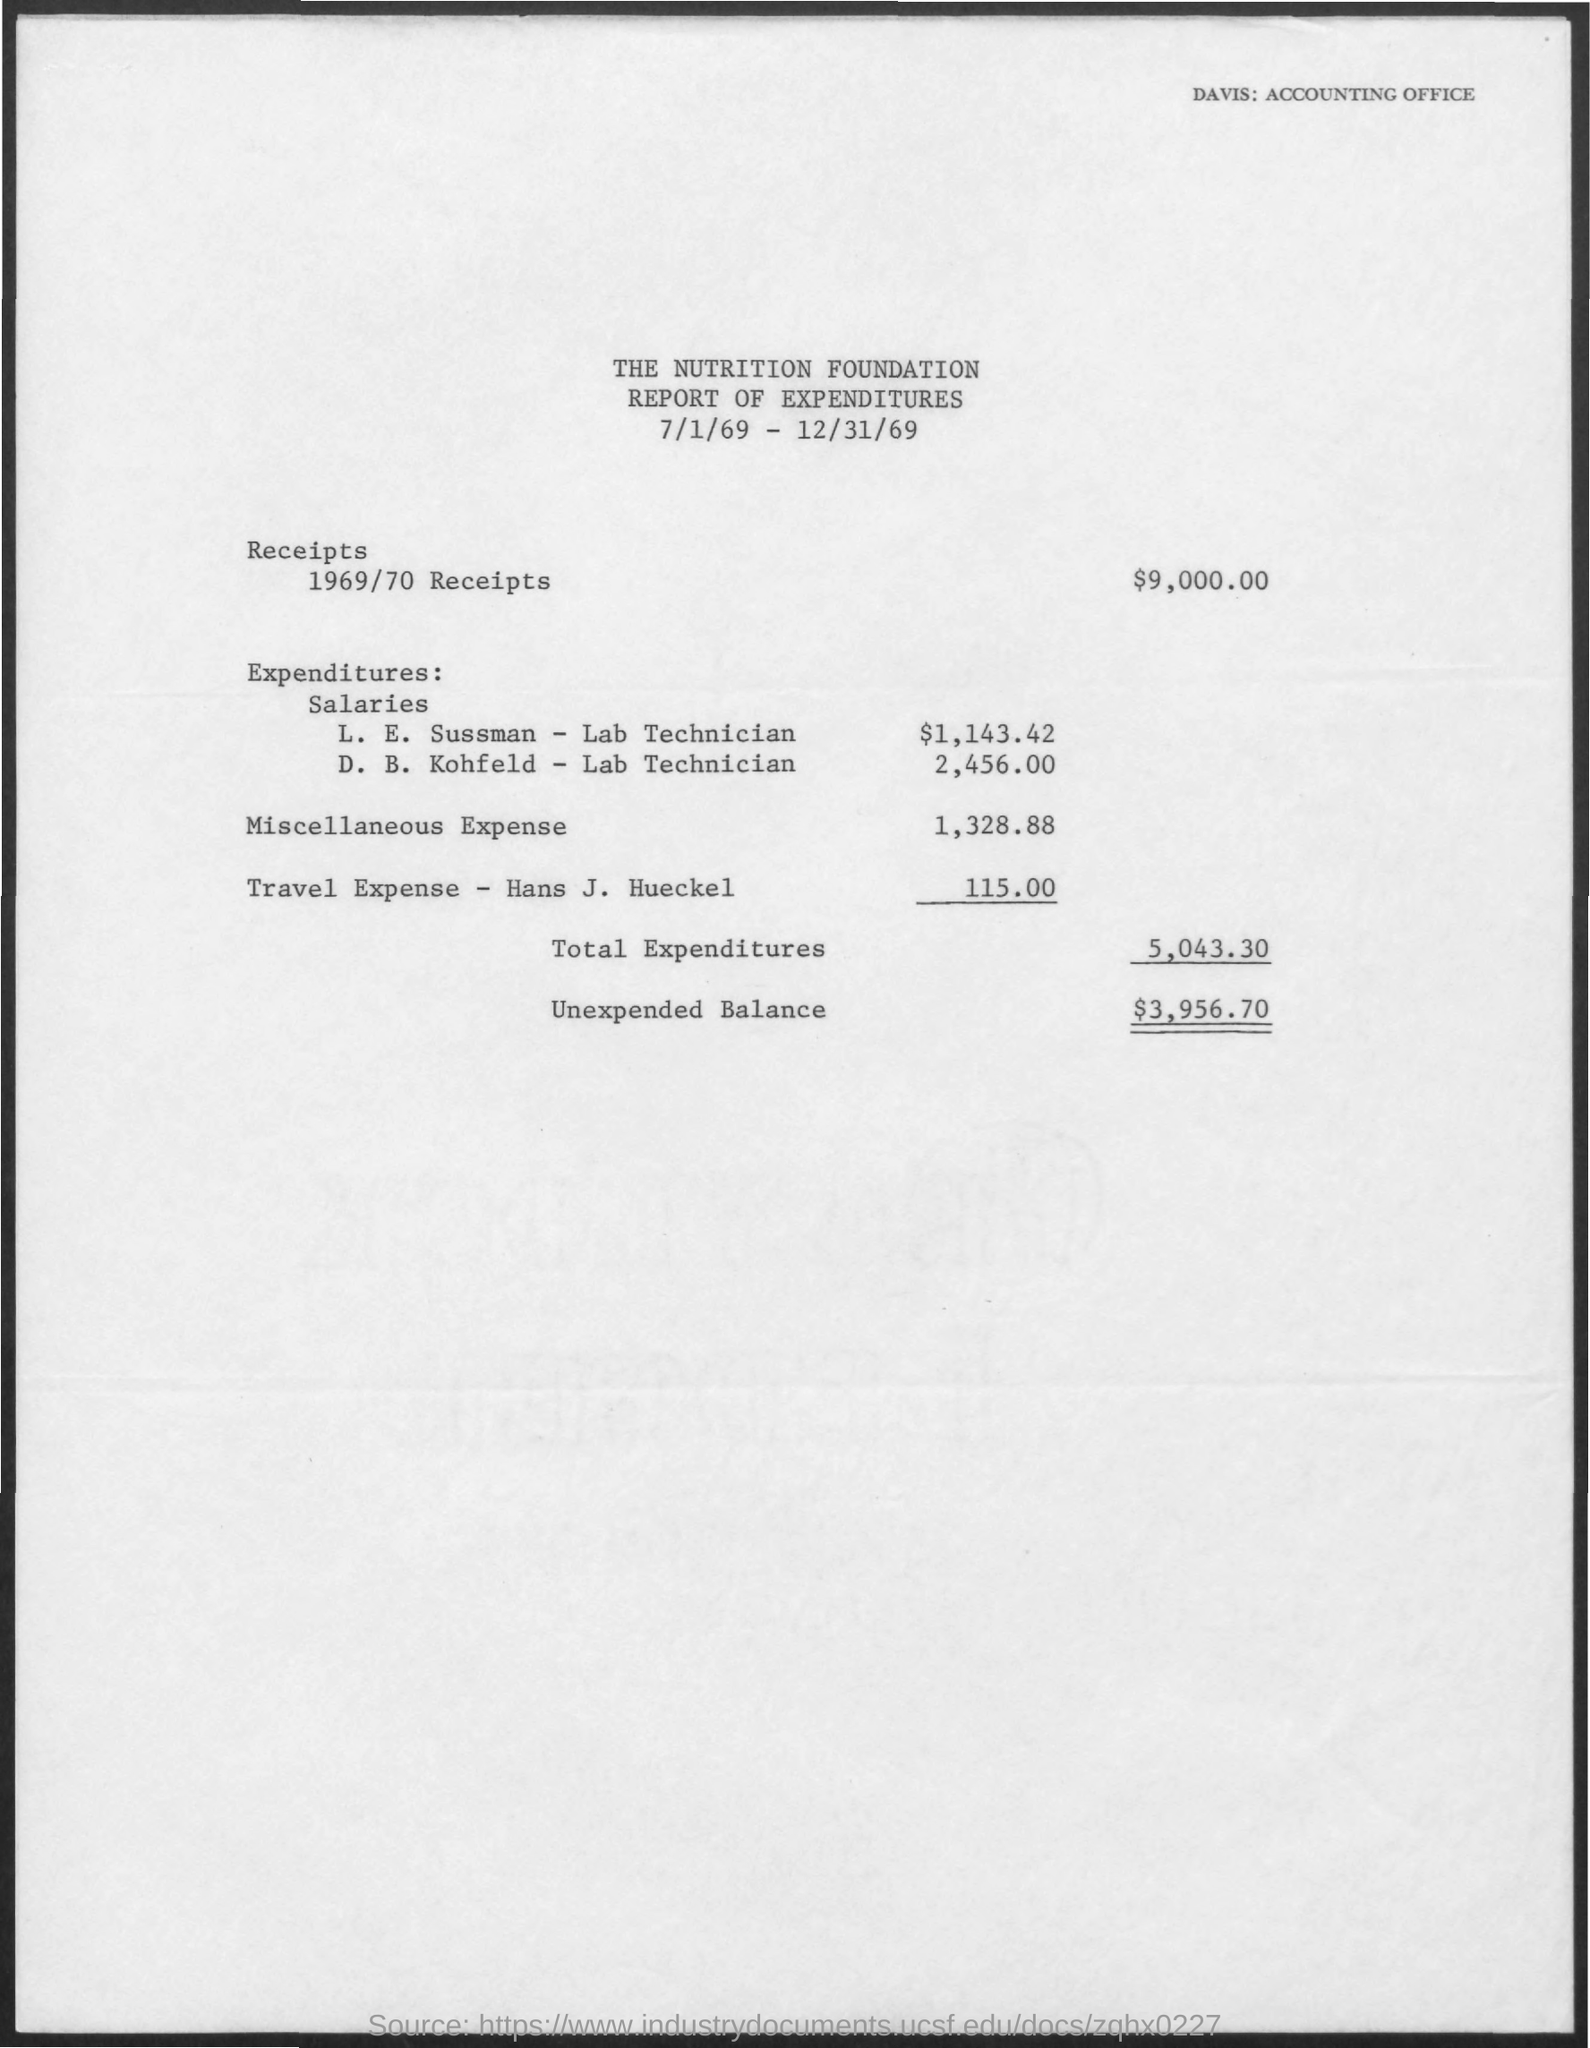Point out several critical features in this image. The amount of unexpected balance mentioned in the given report is $3,956.70. The total expenditures mentioned in the given report are 5,043.30. The amount of receipts for the year 1969/70 was $9,000.00. The salary given to D.B.Kohfeld, a lab technician, is 2,456.00. As of February 2023, the salary of L.E. Sussman, a laboratory technician, was $1,143.42. 